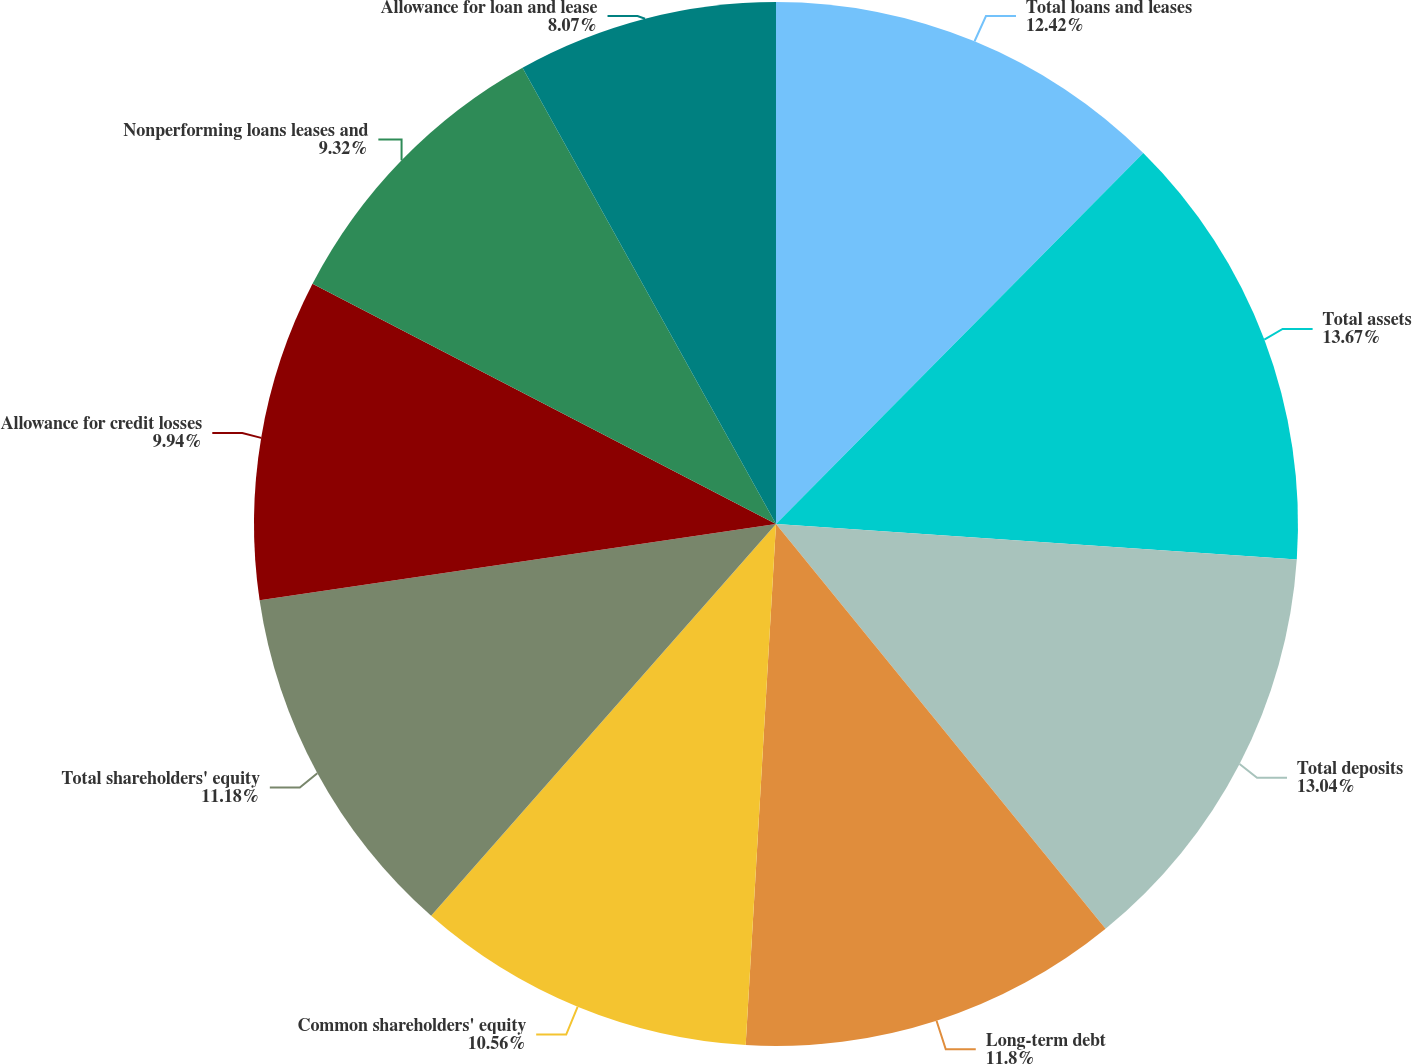Convert chart to OTSL. <chart><loc_0><loc_0><loc_500><loc_500><pie_chart><fcel>Total loans and leases<fcel>Total assets<fcel>Total deposits<fcel>Long-term debt<fcel>Common shareholders' equity<fcel>Total shareholders' equity<fcel>Allowance for credit losses<fcel>Nonperforming loans leases and<fcel>Allowance for loan and lease<nl><fcel>12.42%<fcel>13.66%<fcel>13.04%<fcel>11.8%<fcel>10.56%<fcel>11.18%<fcel>9.94%<fcel>9.32%<fcel>8.07%<nl></chart> 